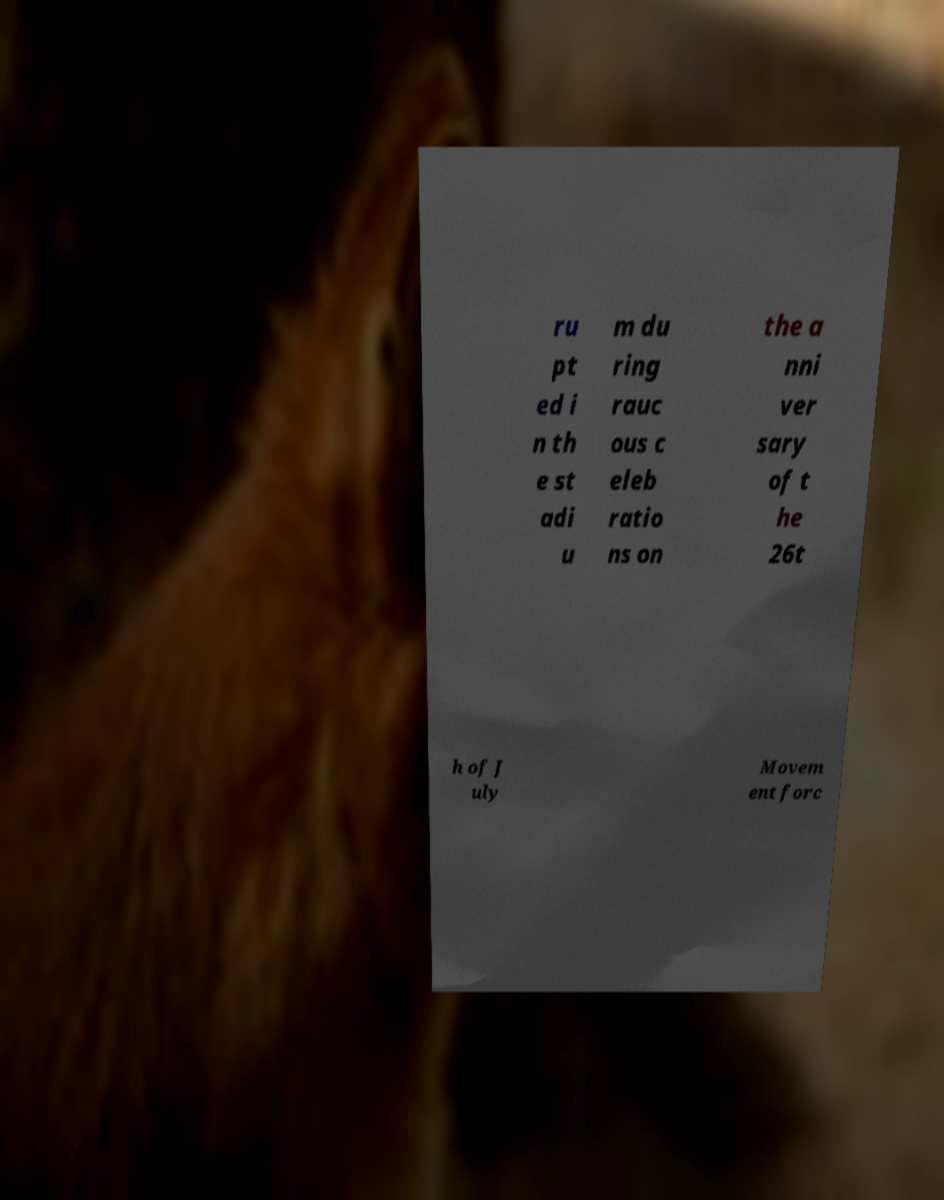Could you assist in decoding the text presented in this image and type it out clearly? ru pt ed i n th e st adi u m du ring rauc ous c eleb ratio ns on the a nni ver sary of t he 26t h of J uly Movem ent forc 